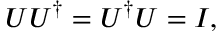Convert formula to latex. <formula><loc_0><loc_0><loc_500><loc_500>U U ^ { \dagger } = U ^ { \dagger } U = I ,</formula> 